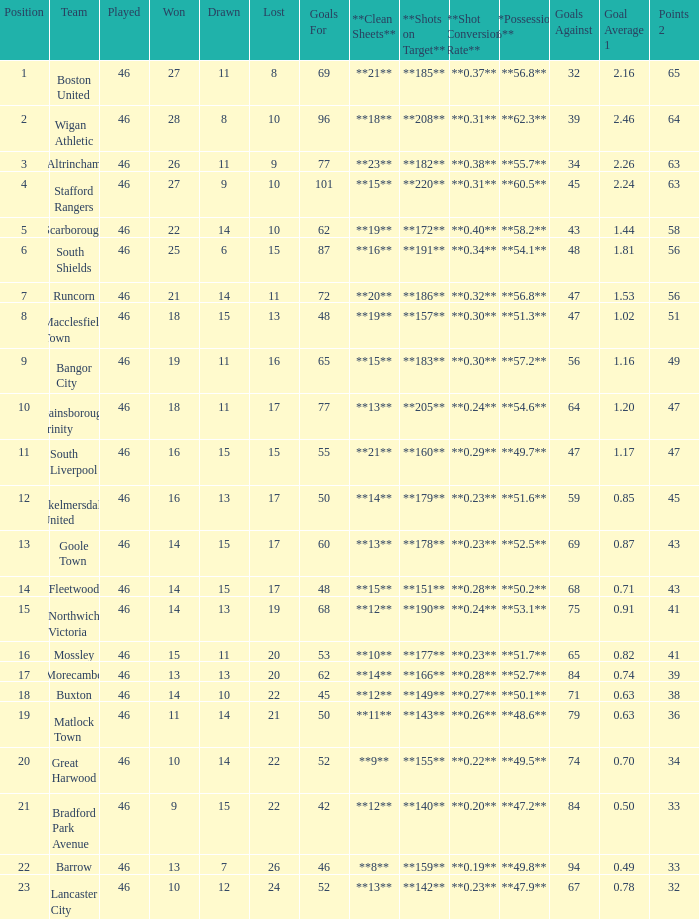How many games did the team who scored 60 goals win? 14.0. 